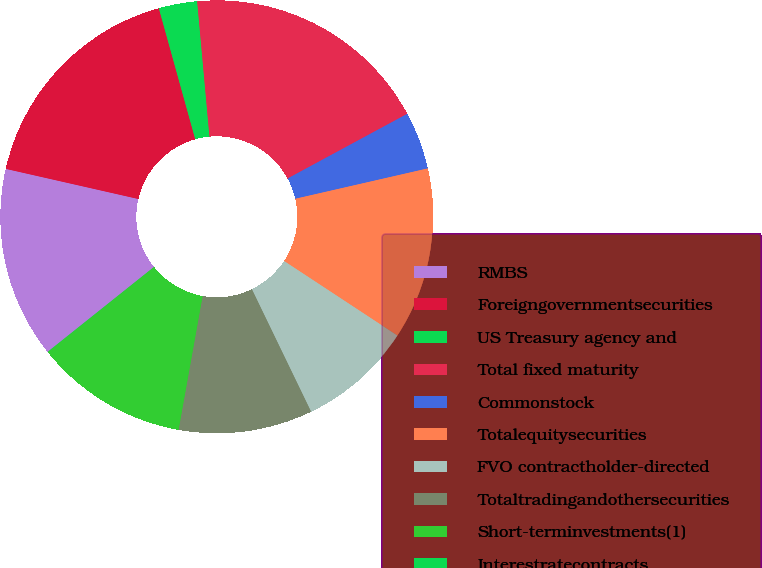Convert chart. <chart><loc_0><loc_0><loc_500><loc_500><pie_chart><fcel>RMBS<fcel>Foreigngovernmentsecurities<fcel>US Treasury agency and<fcel>Total fixed maturity<fcel>Commonstock<fcel>Totalequitysecurities<fcel>FVO contractholder-directed<fcel>Totaltradingandothersecurities<fcel>Short-terminvestments(1)<fcel>Interestratecontracts<nl><fcel>14.28%<fcel>17.13%<fcel>2.87%<fcel>18.56%<fcel>4.3%<fcel>12.85%<fcel>8.57%<fcel>10.0%<fcel>11.43%<fcel>0.02%<nl></chart> 